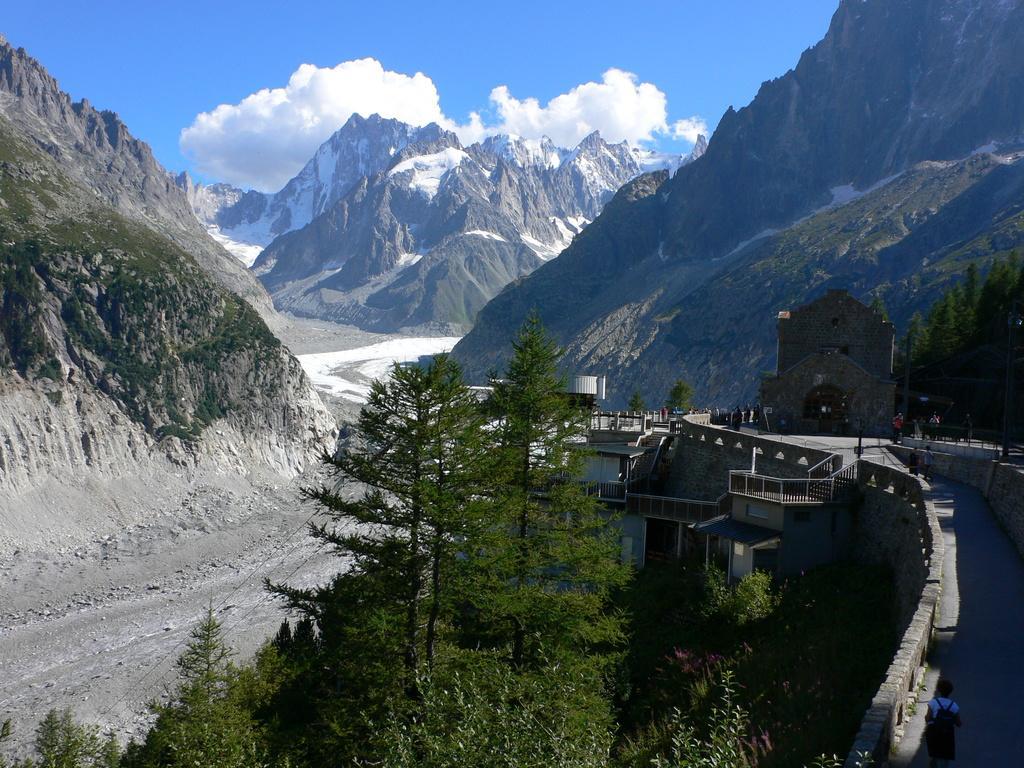Describe this image in one or two sentences. In this image in the front of there are trees and on the right side there is a bridge and there are persons on the bridge and there are trees. In the background there are mountains and the sky is cloudy. 